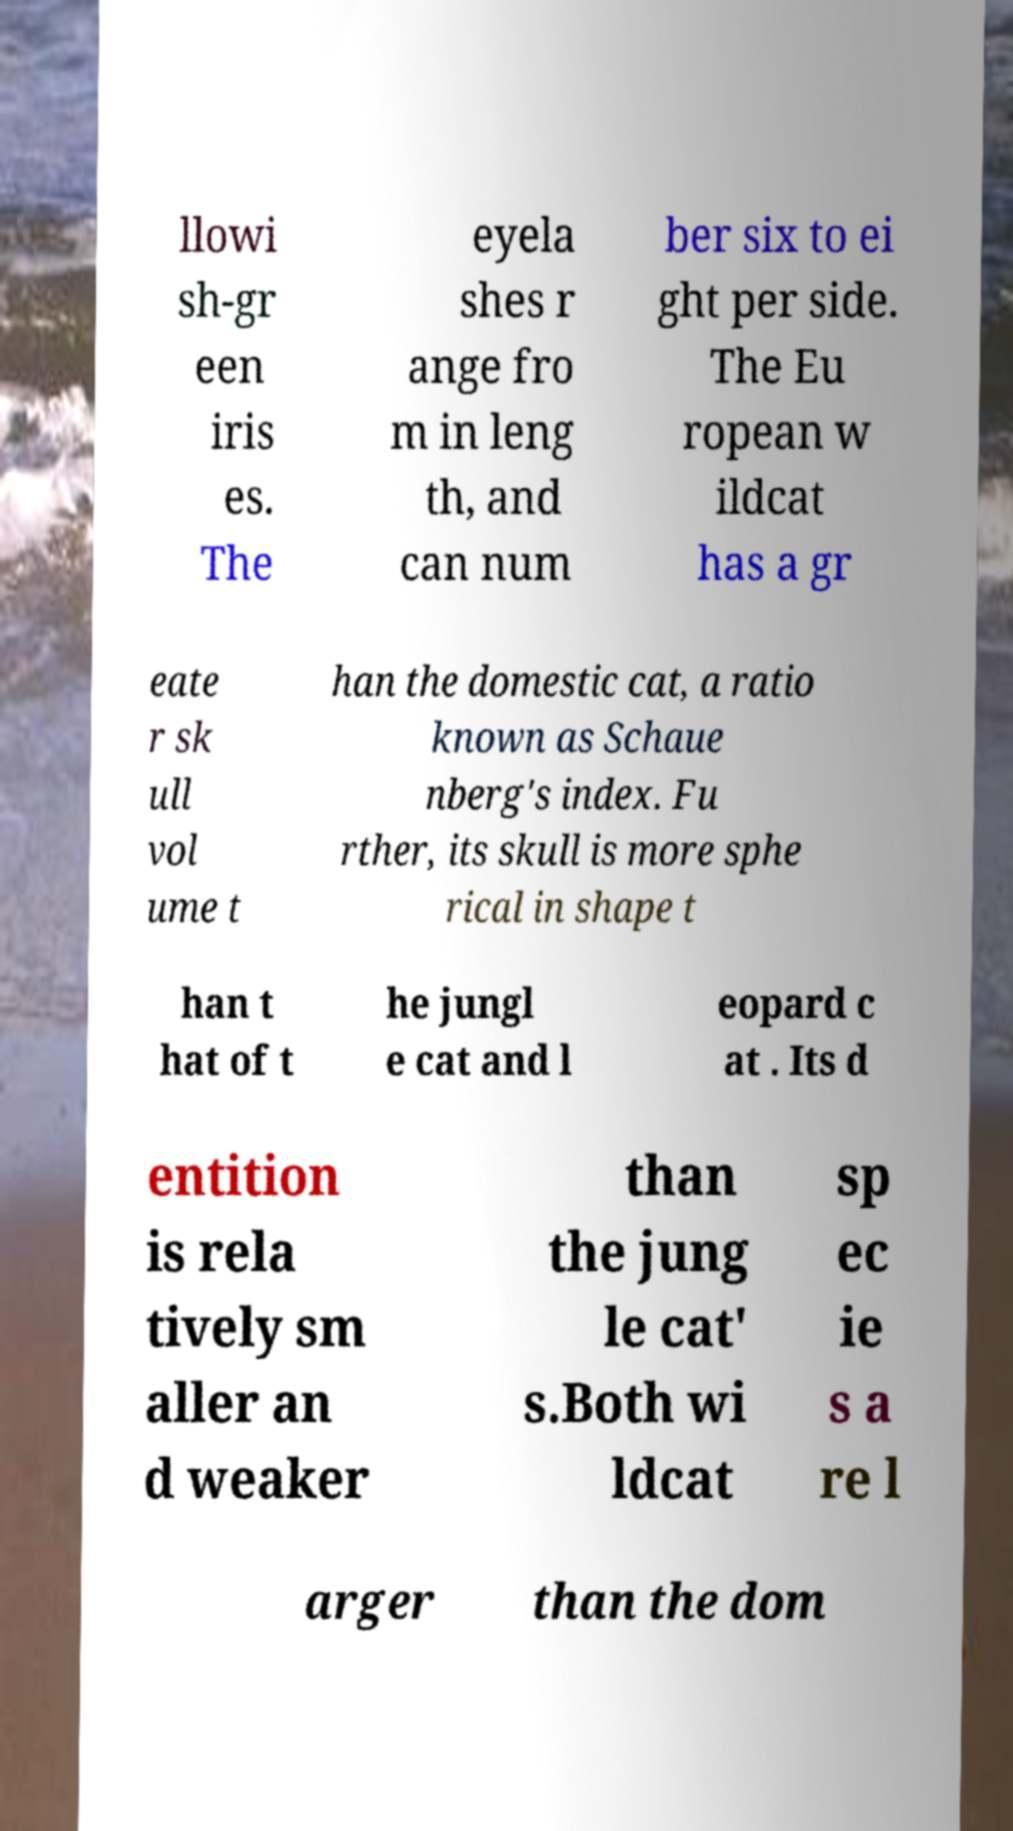I need the written content from this picture converted into text. Can you do that? llowi sh-gr een iris es. The eyela shes r ange fro m in leng th, and can num ber six to ei ght per side. The Eu ropean w ildcat has a gr eate r sk ull vol ume t han the domestic cat, a ratio known as Schaue nberg's index. Fu rther, its skull is more sphe rical in shape t han t hat of t he jungl e cat and l eopard c at . Its d entition is rela tively sm aller an d weaker than the jung le cat' s.Both wi ldcat sp ec ie s a re l arger than the dom 